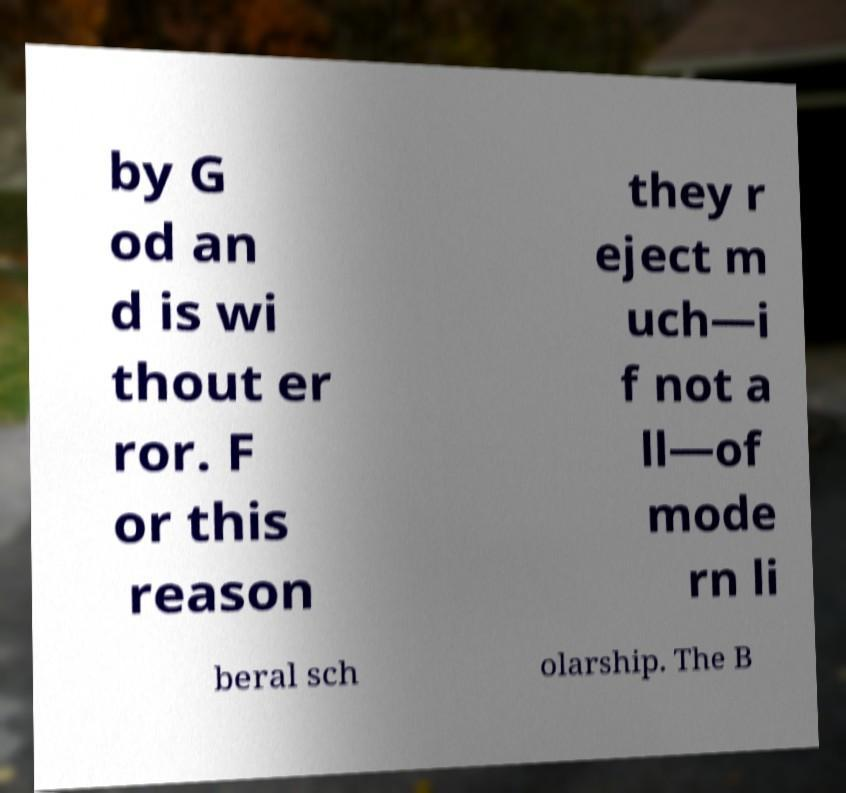What messages or text are displayed in this image? I need them in a readable, typed format. by G od an d is wi thout er ror. F or this reason they r eject m uch—i f not a ll—of mode rn li beral sch olarship. The B 